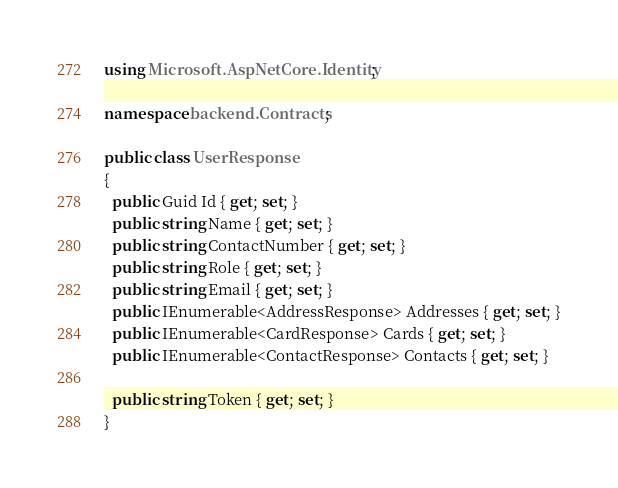Convert code to text. <code><loc_0><loc_0><loc_500><loc_500><_C#_>using Microsoft.AspNetCore.Identity;

namespace backend.Contracts;

public class UserResponse
{
  public Guid Id { get; set; }
  public string Name { get; set; }
  public string ContactNumber { get; set; }
  public string Role { get; set; }
  public string Email { get; set; }
  public IEnumerable<AddressResponse> Addresses { get; set; }
  public IEnumerable<CardResponse> Cards { get; set; }
  public IEnumerable<ContactResponse> Contacts { get; set; }

  public string Token { get; set; }
}</code> 